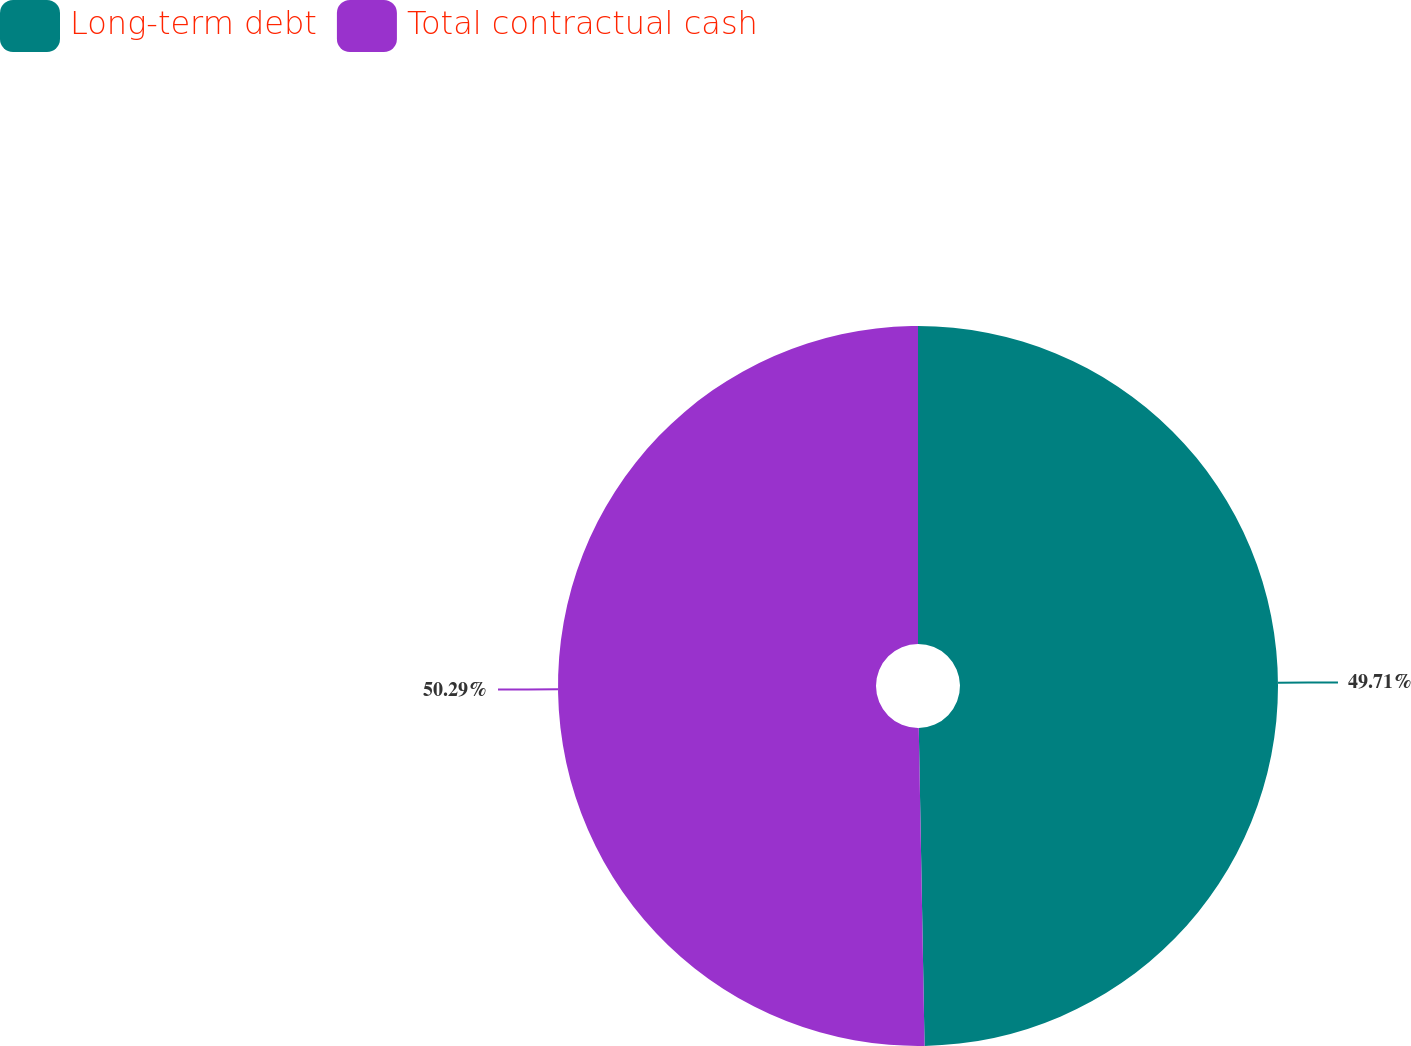<chart> <loc_0><loc_0><loc_500><loc_500><pie_chart><fcel>Long-term debt<fcel>Total contractual cash<nl><fcel>49.71%<fcel>50.29%<nl></chart> 